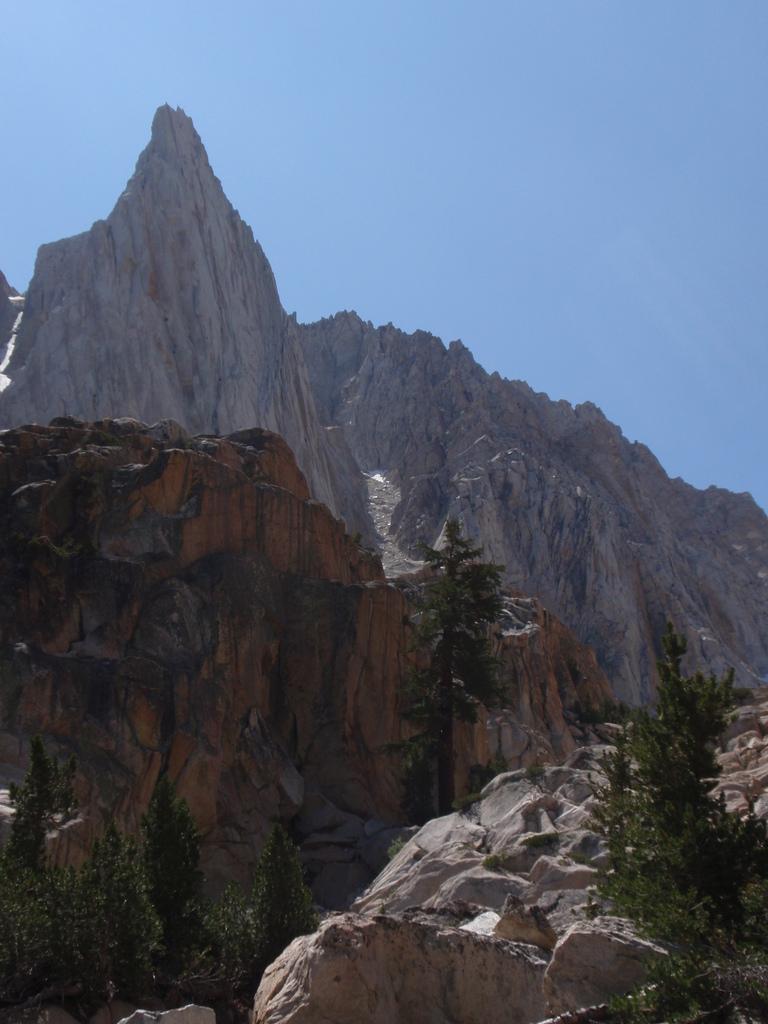Describe this image in one or two sentences. There are trees and rocks. In the background we can see a mountain and sky. 